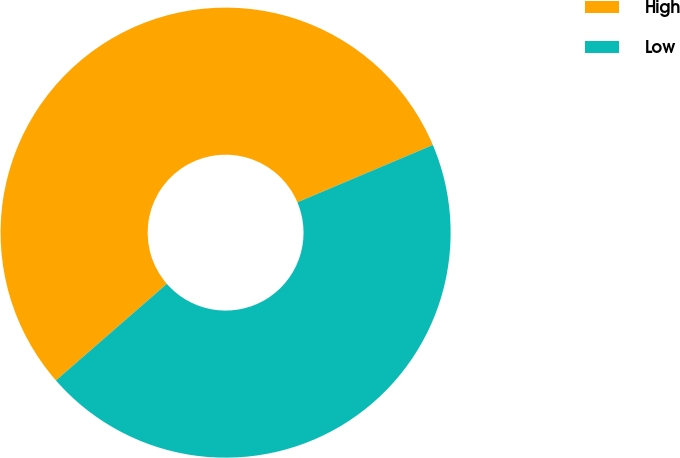<chart> <loc_0><loc_0><loc_500><loc_500><pie_chart><fcel>High<fcel>Low<nl><fcel>55.04%<fcel>44.96%<nl></chart> 